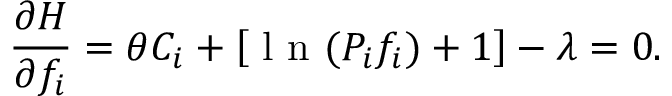Convert formula to latex. <formula><loc_0><loc_0><loc_500><loc_500>\frac { \partial H } { \partial f _ { i } } = \theta C _ { i } + \left [ l n ( P _ { i } f _ { i } ) + 1 \right ] - \lambda = 0 .</formula> 